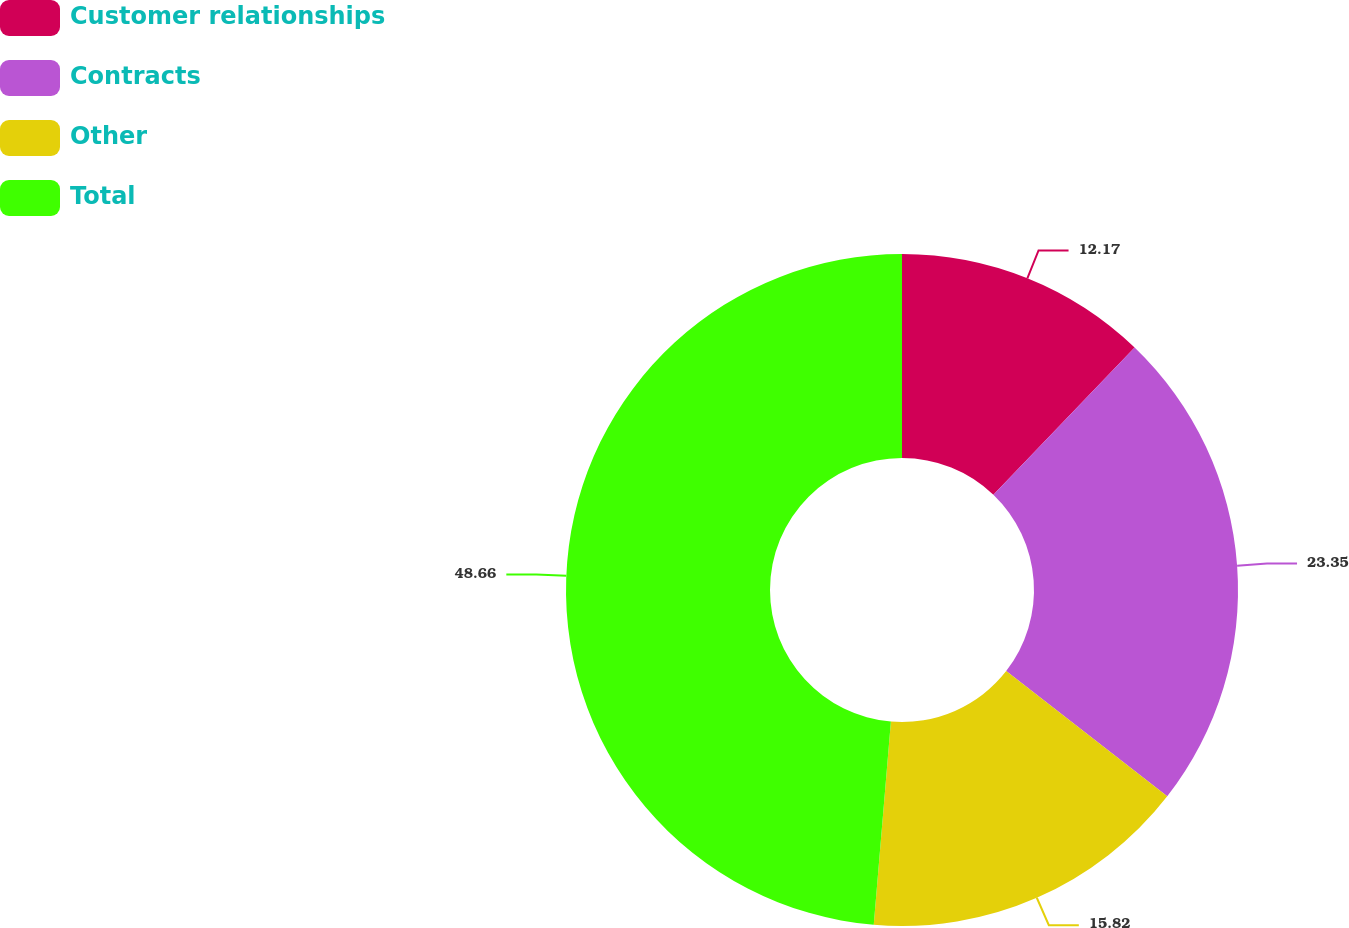Convert chart. <chart><loc_0><loc_0><loc_500><loc_500><pie_chart><fcel>Customer relationships<fcel>Contracts<fcel>Other<fcel>Total<nl><fcel>12.17%<fcel>23.35%<fcel>15.82%<fcel>48.66%<nl></chart> 